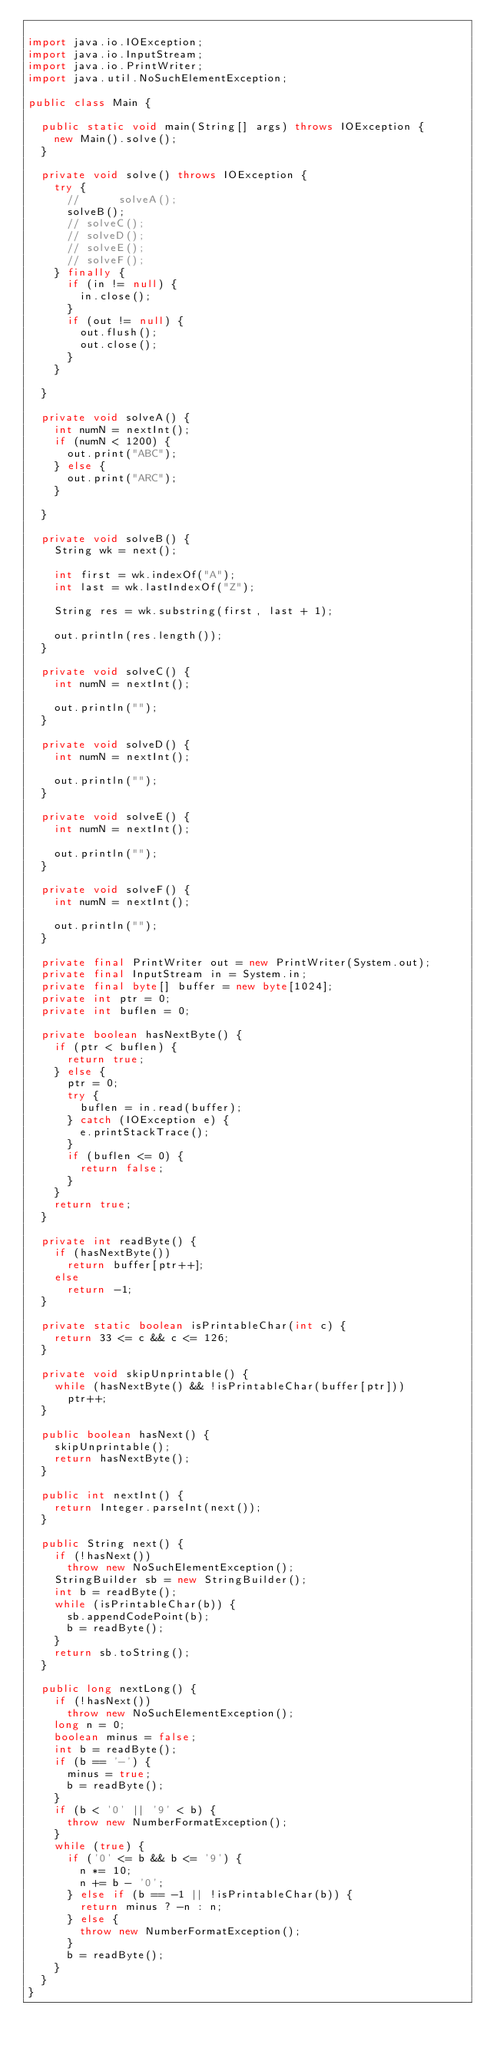Convert code to text. <code><loc_0><loc_0><loc_500><loc_500><_Java_>
import java.io.IOException;
import java.io.InputStream;
import java.io.PrintWriter;
import java.util.NoSuchElementException;

public class Main {

	public static void main(String[] args) throws IOException {
		new Main().solve();
	}

	private void solve() throws IOException {
		try {
			//			solveA();
			solveB();
			// solveC();
			// solveD();
			// solveE();
			// solveF();
		} finally {
			if (in != null) {
				in.close();
			}
			if (out != null) {
				out.flush();
				out.close();
			}
		}

	}

	private void solveA() {
		int numN = nextInt();
		if (numN < 1200) {
			out.print("ABC");
		} else {
			out.print("ARC");
		}

	}

	private void solveB() {
		String wk = next();

		int first = wk.indexOf("A");
		int last = wk.lastIndexOf("Z");

		String res = wk.substring(first, last + 1);

		out.println(res.length());
	}

	private void solveC() {
		int numN = nextInt();

		out.println("");
	}

	private void solveD() {
		int numN = nextInt();

		out.println("");
	}

	private void solveE() {
		int numN = nextInt();

		out.println("");
	}

	private void solveF() {
		int numN = nextInt();

		out.println("");
	}

	private final PrintWriter out = new PrintWriter(System.out);
	private final InputStream in = System.in;
	private final byte[] buffer = new byte[1024];
	private int ptr = 0;
	private int buflen = 0;

	private boolean hasNextByte() {
		if (ptr < buflen) {
			return true;
		} else {
			ptr = 0;
			try {
				buflen = in.read(buffer);
			} catch (IOException e) {
				e.printStackTrace();
			}
			if (buflen <= 0) {
				return false;
			}
		}
		return true;
	}

	private int readByte() {
		if (hasNextByte())
			return buffer[ptr++];
		else
			return -1;
	}

	private static boolean isPrintableChar(int c) {
		return 33 <= c && c <= 126;
	}

	private void skipUnprintable() {
		while (hasNextByte() && !isPrintableChar(buffer[ptr]))
			ptr++;
	}

	public boolean hasNext() {
		skipUnprintable();
		return hasNextByte();
	}

	public int nextInt() {
		return Integer.parseInt(next());
	}

	public String next() {
		if (!hasNext())
			throw new NoSuchElementException();
		StringBuilder sb = new StringBuilder();
		int b = readByte();
		while (isPrintableChar(b)) {
			sb.appendCodePoint(b);
			b = readByte();
		}
		return sb.toString();
	}

	public long nextLong() {
		if (!hasNext())
			throw new NoSuchElementException();
		long n = 0;
		boolean minus = false;
		int b = readByte();
		if (b == '-') {
			minus = true;
			b = readByte();
		}
		if (b < '0' || '9' < b) {
			throw new NumberFormatException();
		}
		while (true) {
			if ('0' <= b && b <= '9') {
				n *= 10;
				n += b - '0';
			} else if (b == -1 || !isPrintableChar(b)) {
				return minus ? -n : n;
			} else {
				throw new NumberFormatException();
			}
			b = readByte();
		}
	}
}</code> 